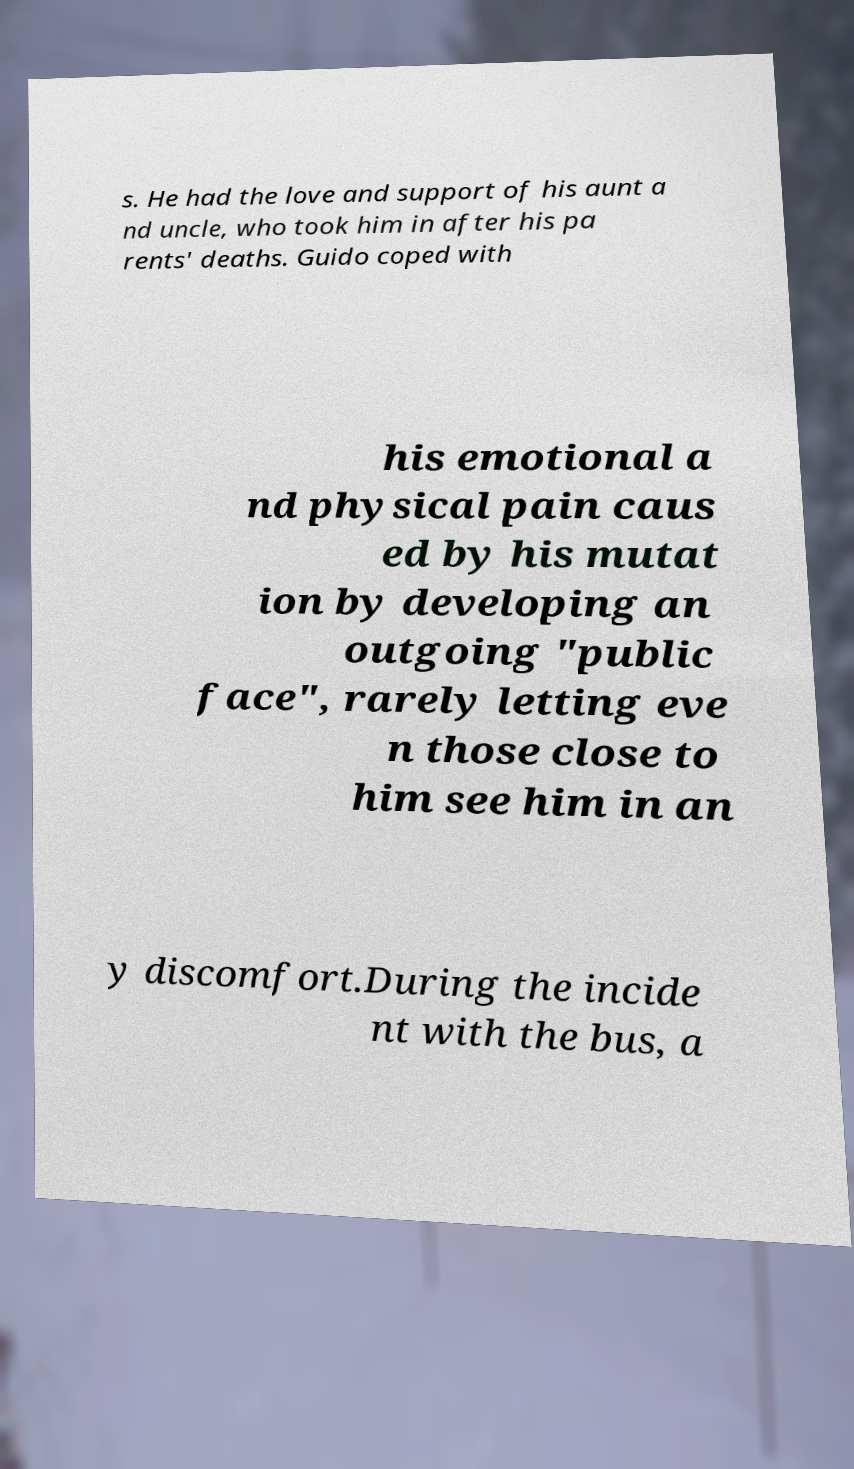I need the written content from this picture converted into text. Can you do that? s. He had the love and support of his aunt a nd uncle, who took him in after his pa rents' deaths. Guido coped with his emotional a nd physical pain caus ed by his mutat ion by developing an outgoing "public face", rarely letting eve n those close to him see him in an y discomfort.During the incide nt with the bus, a 